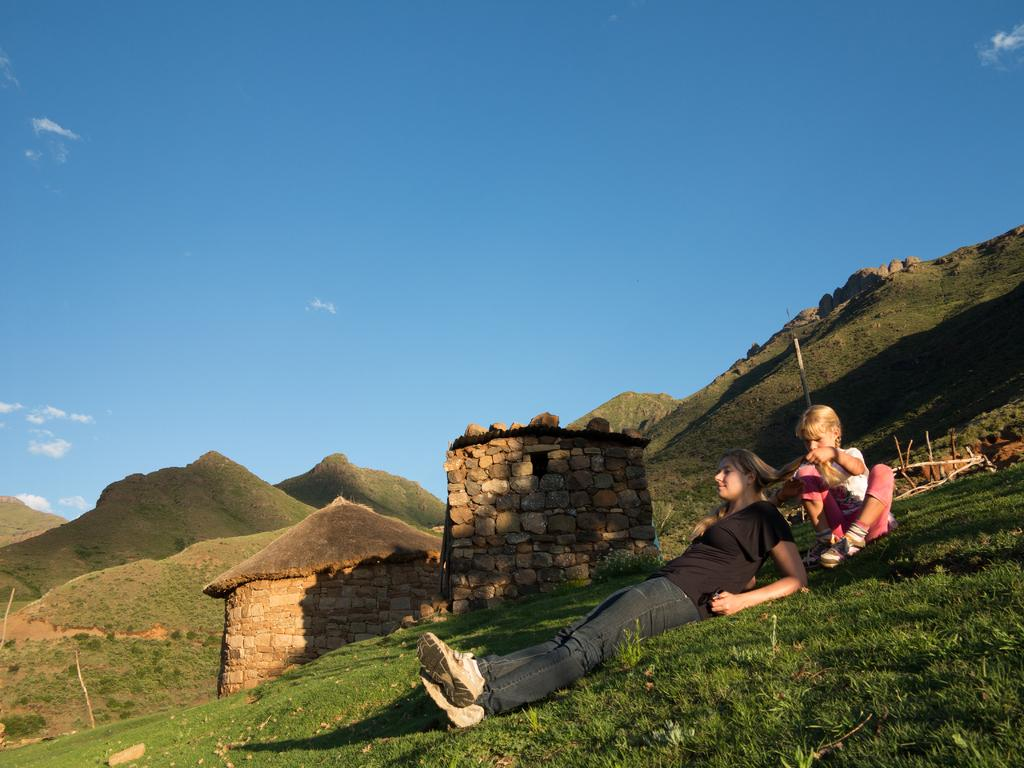What is the position of the woman in the image? There is a woman lying down in the image. What is the girl in the image doing? There is a girl sitting in the image. What type of vegetation is visible in the image? There is grass visible in the image. What type of structures can be seen in the image? There are huts in the image. What type of natural landform is visible in the image? There are hills in the image. What is visible in the sky in the image? The sky is visible in the image. What type of insect is crawling on the table in the image? There is no table present in the image, and therefore no insect crawling on it. 